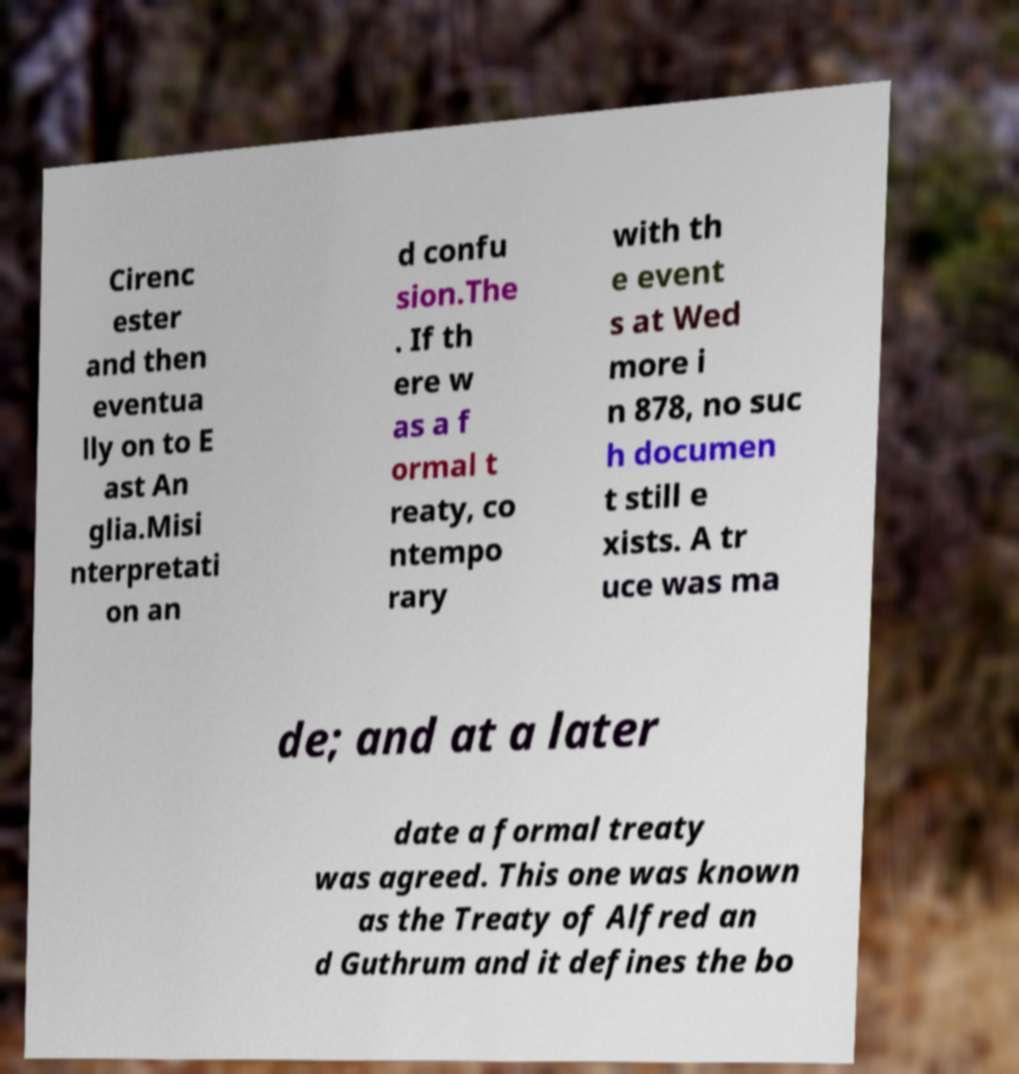Could you extract and type out the text from this image? Cirenc ester and then eventua lly on to E ast An glia.Misi nterpretati on an d confu sion.The . If th ere w as a f ormal t reaty, co ntempo rary with th e event s at Wed more i n 878, no suc h documen t still e xists. A tr uce was ma de; and at a later date a formal treaty was agreed. This one was known as the Treaty of Alfred an d Guthrum and it defines the bo 